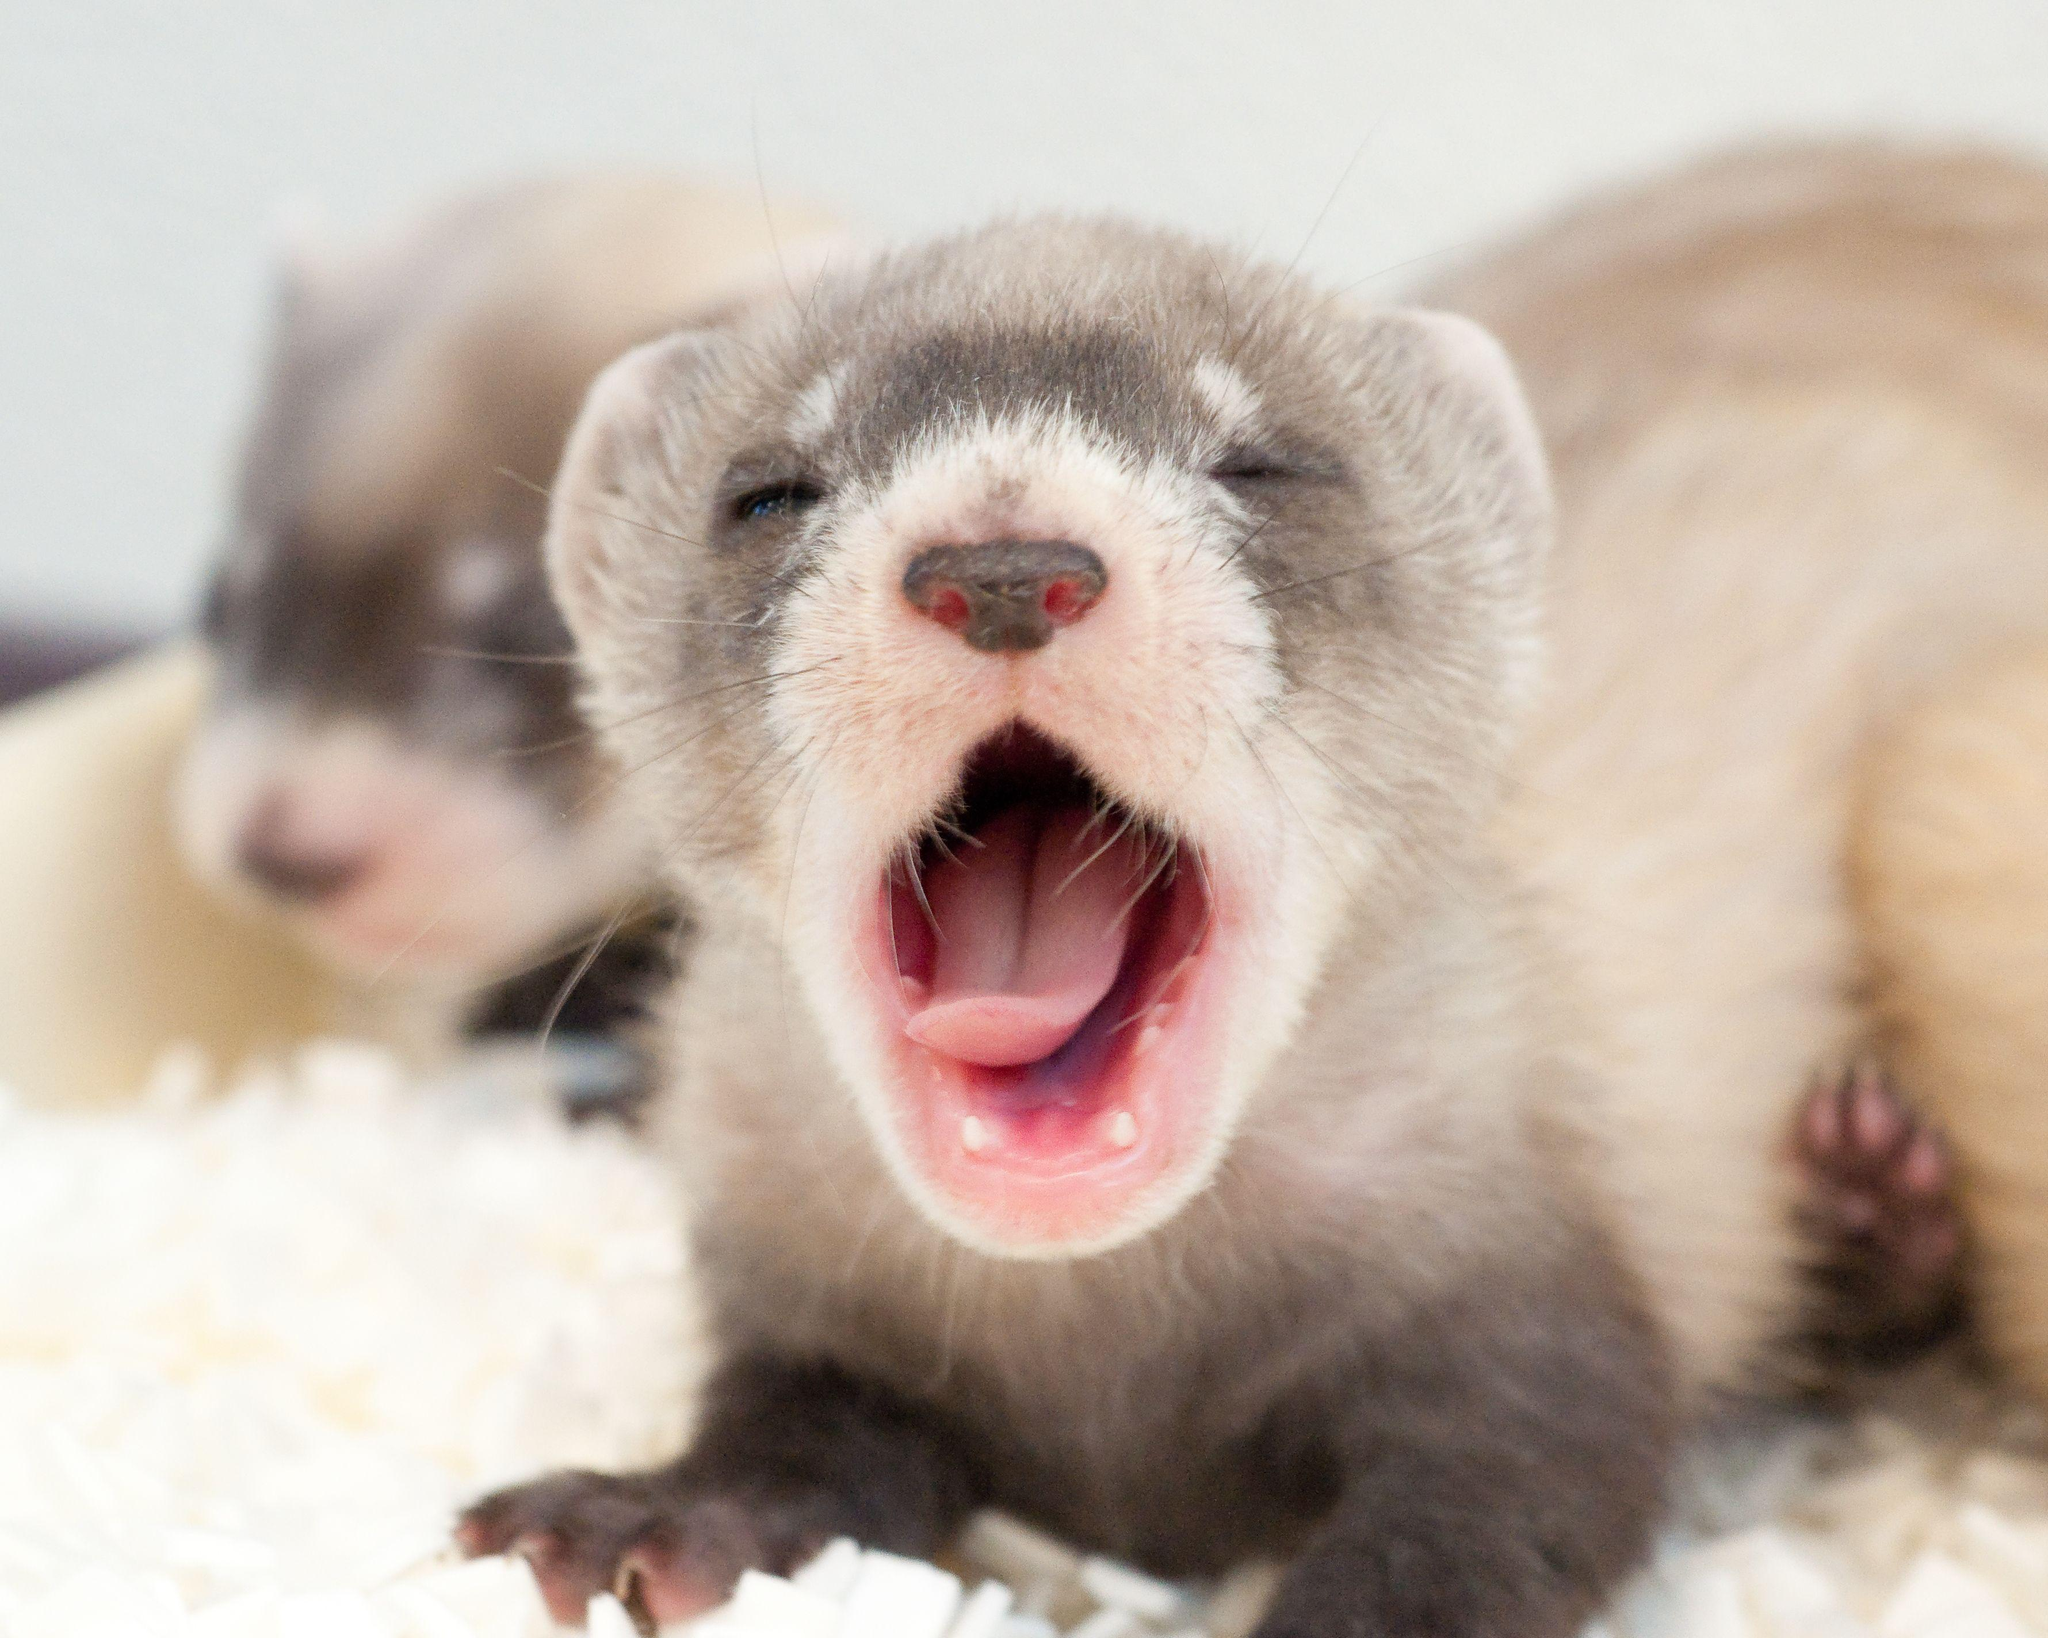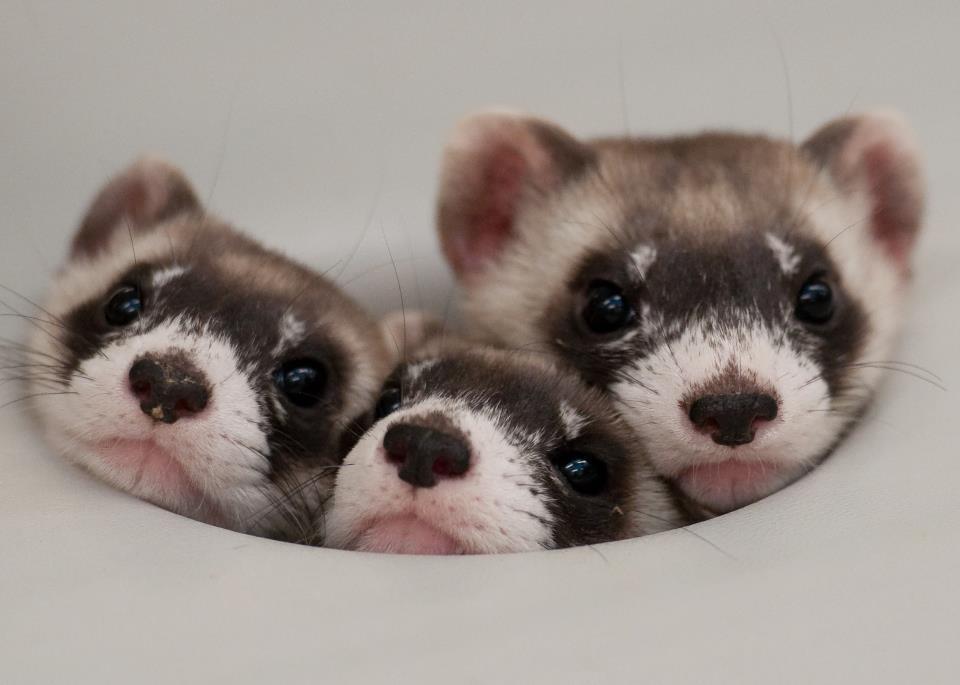The first image is the image on the left, the second image is the image on the right. Considering the images on both sides, is "At least one photograph shows exactly one animal with light brown, rather than black, markings around its eyes." valid? Answer yes or no. Yes. The first image is the image on the left, the second image is the image on the right. Assess this claim about the two images: "There is only one weasel coming out of a hole in one of the pictures.". Correct or not? Answer yes or no. No. 